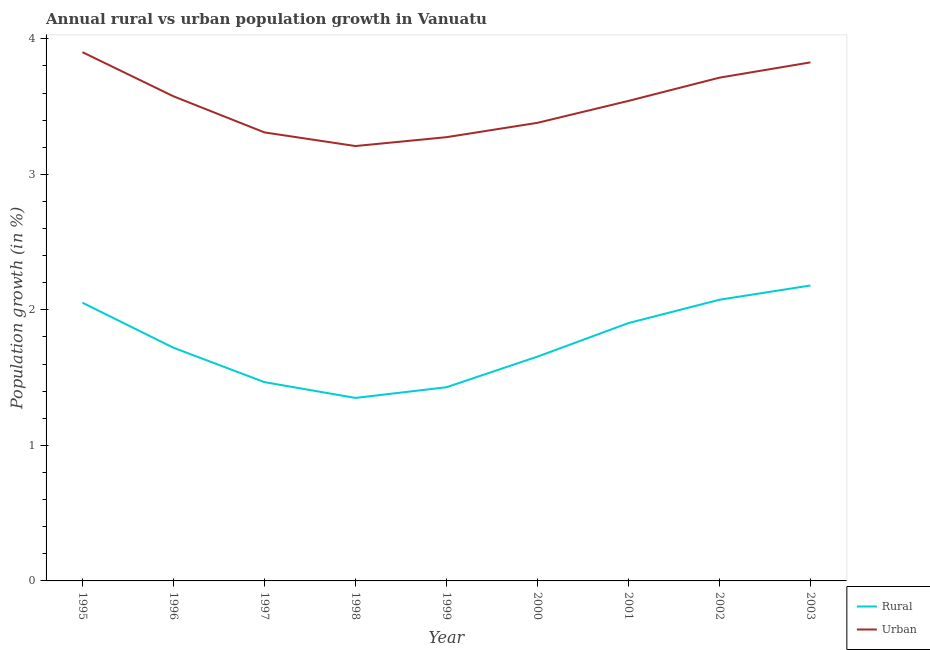How many different coloured lines are there?
Your answer should be very brief. 2. Is the number of lines equal to the number of legend labels?
Your response must be concise. Yes. What is the urban population growth in 1998?
Your answer should be very brief. 3.21. Across all years, what is the maximum rural population growth?
Provide a succinct answer. 2.18. Across all years, what is the minimum rural population growth?
Make the answer very short. 1.35. In which year was the rural population growth minimum?
Ensure brevity in your answer.  1998. What is the total urban population growth in the graph?
Make the answer very short. 31.73. What is the difference between the urban population growth in 1995 and that in 1996?
Make the answer very short. 0.33. What is the difference between the rural population growth in 1996 and the urban population growth in 1997?
Your response must be concise. -1.59. What is the average urban population growth per year?
Your answer should be very brief. 3.53. In the year 1995, what is the difference between the urban population growth and rural population growth?
Keep it short and to the point. 1.85. In how many years, is the rural population growth greater than 3.8 %?
Your answer should be very brief. 0. What is the ratio of the rural population growth in 1996 to that in 1997?
Your answer should be compact. 1.17. What is the difference between the highest and the second highest urban population growth?
Your answer should be very brief. 0.08. What is the difference between the highest and the lowest urban population growth?
Your answer should be compact. 0.69. Is the sum of the rural population growth in 1995 and 2003 greater than the maximum urban population growth across all years?
Give a very brief answer. Yes. Is the urban population growth strictly less than the rural population growth over the years?
Offer a terse response. No. How many years are there in the graph?
Keep it short and to the point. 9. What is the difference between two consecutive major ticks on the Y-axis?
Offer a terse response. 1. How many legend labels are there?
Make the answer very short. 2. What is the title of the graph?
Your answer should be compact. Annual rural vs urban population growth in Vanuatu. What is the label or title of the X-axis?
Your response must be concise. Year. What is the label or title of the Y-axis?
Ensure brevity in your answer.  Population growth (in %). What is the Population growth (in %) in Rural in 1995?
Provide a succinct answer. 2.05. What is the Population growth (in %) of Urban  in 1995?
Your response must be concise. 3.9. What is the Population growth (in %) in Rural in 1996?
Offer a very short reply. 1.72. What is the Population growth (in %) of Urban  in 1996?
Offer a very short reply. 3.58. What is the Population growth (in %) of Rural in 1997?
Offer a terse response. 1.47. What is the Population growth (in %) in Urban  in 1997?
Provide a short and direct response. 3.31. What is the Population growth (in %) in Rural in 1998?
Your answer should be very brief. 1.35. What is the Population growth (in %) in Urban  in 1998?
Offer a terse response. 3.21. What is the Population growth (in %) of Rural in 1999?
Provide a short and direct response. 1.43. What is the Population growth (in %) of Urban  in 1999?
Give a very brief answer. 3.27. What is the Population growth (in %) of Rural in 2000?
Your answer should be very brief. 1.65. What is the Population growth (in %) of Urban  in 2000?
Ensure brevity in your answer.  3.38. What is the Population growth (in %) of Rural in 2001?
Make the answer very short. 1.9. What is the Population growth (in %) in Urban  in 2001?
Your answer should be compact. 3.54. What is the Population growth (in %) in Rural in 2002?
Provide a succinct answer. 2.07. What is the Population growth (in %) in Urban  in 2002?
Your response must be concise. 3.71. What is the Population growth (in %) of Rural in 2003?
Provide a succinct answer. 2.18. What is the Population growth (in %) in Urban  in 2003?
Offer a terse response. 3.83. Across all years, what is the maximum Population growth (in %) of Rural?
Give a very brief answer. 2.18. Across all years, what is the maximum Population growth (in %) in Urban ?
Offer a very short reply. 3.9. Across all years, what is the minimum Population growth (in %) in Rural?
Give a very brief answer. 1.35. Across all years, what is the minimum Population growth (in %) in Urban ?
Ensure brevity in your answer.  3.21. What is the total Population growth (in %) of Rural in the graph?
Offer a very short reply. 15.83. What is the total Population growth (in %) of Urban  in the graph?
Ensure brevity in your answer.  31.73. What is the difference between the Population growth (in %) of Rural in 1995 and that in 1996?
Give a very brief answer. 0.33. What is the difference between the Population growth (in %) of Urban  in 1995 and that in 1996?
Your response must be concise. 0.33. What is the difference between the Population growth (in %) of Rural in 1995 and that in 1997?
Your answer should be very brief. 0.59. What is the difference between the Population growth (in %) of Urban  in 1995 and that in 1997?
Provide a succinct answer. 0.59. What is the difference between the Population growth (in %) of Rural in 1995 and that in 1998?
Provide a short and direct response. 0.7. What is the difference between the Population growth (in %) in Urban  in 1995 and that in 1998?
Your answer should be compact. 0.69. What is the difference between the Population growth (in %) of Rural in 1995 and that in 1999?
Ensure brevity in your answer.  0.62. What is the difference between the Population growth (in %) of Urban  in 1995 and that in 1999?
Provide a short and direct response. 0.63. What is the difference between the Population growth (in %) in Rural in 1995 and that in 2000?
Your answer should be very brief. 0.4. What is the difference between the Population growth (in %) in Urban  in 1995 and that in 2000?
Offer a terse response. 0.52. What is the difference between the Population growth (in %) in Rural in 1995 and that in 2001?
Ensure brevity in your answer.  0.15. What is the difference between the Population growth (in %) in Urban  in 1995 and that in 2001?
Give a very brief answer. 0.36. What is the difference between the Population growth (in %) in Rural in 1995 and that in 2002?
Your response must be concise. -0.02. What is the difference between the Population growth (in %) in Urban  in 1995 and that in 2002?
Make the answer very short. 0.19. What is the difference between the Population growth (in %) in Rural in 1995 and that in 2003?
Provide a short and direct response. -0.13. What is the difference between the Population growth (in %) of Urban  in 1995 and that in 2003?
Ensure brevity in your answer.  0.08. What is the difference between the Population growth (in %) in Rural in 1996 and that in 1997?
Your response must be concise. 0.25. What is the difference between the Population growth (in %) in Urban  in 1996 and that in 1997?
Offer a very short reply. 0.27. What is the difference between the Population growth (in %) of Rural in 1996 and that in 1998?
Your response must be concise. 0.37. What is the difference between the Population growth (in %) of Urban  in 1996 and that in 1998?
Offer a very short reply. 0.37. What is the difference between the Population growth (in %) in Rural in 1996 and that in 1999?
Give a very brief answer. 0.29. What is the difference between the Population growth (in %) in Urban  in 1996 and that in 1999?
Offer a terse response. 0.3. What is the difference between the Population growth (in %) of Rural in 1996 and that in 2000?
Make the answer very short. 0.07. What is the difference between the Population growth (in %) of Urban  in 1996 and that in 2000?
Your answer should be compact. 0.2. What is the difference between the Population growth (in %) of Rural in 1996 and that in 2001?
Offer a very short reply. -0.18. What is the difference between the Population growth (in %) in Urban  in 1996 and that in 2001?
Provide a short and direct response. 0.03. What is the difference between the Population growth (in %) in Rural in 1996 and that in 2002?
Provide a succinct answer. -0.35. What is the difference between the Population growth (in %) in Urban  in 1996 and that in 2002?
Provide a succinct answer. -0.14. What is the difference between the Population growth (in %) of Rural in 1996 and that in 2003?
Ensure brevity in your answer.  -0.46. What is the difference between the Population growth (in %) of Urban  in 1996 and that in 2003?
Offer a terse response. -0.25. What is the difference between the Population growth (in %) of Rural in 1997 and that in 1998?
Keep it short and to the point. 0.12. What is the difference between the Population growth (in %) in Urban  in 1997 and that in 1998?
Ensure brevity in your answer.  0.1. What is the difference between the Population growth (in %) of Rural in 1997 and that in 1999?
Your answer should be very brief. 0.04. What is the difference between the Population growth (in %) in Urban  in 1997 and that in 1999?
Provide a short and direct response. 0.04. What is the difference between the Population growth (in %) in Rural in 1997 and that in 2000?
Ensure brevity in your answer.  -0.19. What is the difference between the Population growth (in %) of Urban  in 1997 and that in 2000?
Provide a short and direct response. -0.07. What is the difference between the Population growth (in %) in Rural in 1997 and that in 2001?
Keep it short and to the point. -0.44. What is the difference between the Population growth (in %) in Urban  in 1997 and that in 2001?
Keep it short and to the point. -0.23. What is the difference between the Population growth (in %) in Rural in 1997 and that in 2002?
Your answer should be very brief. -0.61. What is the difference between the Population growth (in %) in Urban  in 1997 and that in 2002?
Your answer should be compact. -0.4. What is the difference between the Population growth (in %) of Rural in 1997 and that in 2003?
Your answer should be very brief. -0.71. What is the difference between the Population growth (in %) of Urban  in 1997 and that in 2003?
Provide a short and direct response. -0.52. What is the difference between the Population growth (in %) of Rural in 1998 and that in 1999?
Give a very brief answer. -0.08. What is the difference between the Population growth (in %) of Urban  in 1998 and that in 1999?
Your response must be concise. -0.07. What is the difference between the Population growth (in %) in Rural in 1998 and that in 2000?
Give a very brief answer. -0.3. What is the difference between the Population growth (in %) in Urban  in 1998 and that in 2000?
Make the answer very short. -0.17. What is the difference between the Population growth (in %) in Rural in 1998 and that in 2001?
Provide a short and direct response. -0.55. What is the difference between the Population growth (in %) in Urban  in 1998 and that in 2001?
Provide a succinct answer. -0.33. What is the difference between the Population growth (in %) in Rural in 1998 and that in 2002?
Make the answer very short. -0.72. What is the difference between the Population growth (in %) in Urban  in 1998 and that in 2002?
Provide a short and direct response. -0.5. What is the difference between the Population growth (in %) of Rural in 1998 and that in 2003?
Your answer should be very brief. -0.83. What is the difference between the Population growth (in %) in Urban  in 1998 and that in 2003?
Provide a short and direct response. -0.62. What is the difference between the Population growth (in %) of Rural in 1999 and that in 2000?
Your answer should be very brief. -0.23. What is the difference between the Population growth (in %) of Urban  in 1999 and that in 2000?
Offer a very short reply. -0.11. What is the difference between the Population growth (in %) in Rural in 1999 and that in 2001?
Give a very brief answer. -0.47. What is the difference between the Population growth (in %) in Urban  in 1999 and that in 2001?
Provide a succinct answer. -0.27. What is the difference between the Population growth (in %) in Rural in 1999 and that in 2002?
Your answer should be very brief. -0.65. What is the difference between the Population growth (in %) of Urban  in 1999 and that in 2002?
Your answer should be very brief. -0.44. What is the difference between the Population growth (in %) of Rural in 1999 and that in 2003?
Provide a short and direct response. -0.75. What is the difference between the Population growth (in %) of Urban  in 1999 and that in 2003?
Your response must be concise. -0.55. What is the difference between the Population growth (in %) of Rural in 2000 and that in 2001?
Your answer should be very brief. -0.25. What is the difference between the Population growth (in %) in Urban  in 2000 and that in 2001?
Offer a terse response. -0.16. What is the difference between the Population growth (in %) in Rural in 2000 and that in 2002?
Make the answer very short. -0.42. What is the difference between the Population growth (in %) in Urban  in 2000 and that in 2002?
Give a very brief answer. -0.33. What is the difference between the Population growth (in %) in Rural in 2000 and that in 2003?
Provide a succinct answer. -0.53. What is the difference between the Population growth (in %) of Urban  in 2000 and that in 2003?
Ensure brevity in your answer.  -0.45. What is the difference between the Population growth (in %) in Rural in 2001 and that in 2002?
Provide a short and direct response. -0.17. What is the difference between the Population growth (in %) in Urban  in 2001 and that in 2002?
Your answer should be very brief. -0.17. What is the difference between the Population growth (in %) in Rural in 2001 and that in 2003?
Your answer should be compact. -0.28. What is the difference between the Population growth (in %) of Urban  in 2001 and that in 2003?
Provide a succinct answer. -0.28. What is the difference between the Population growth (in %) of Rural in 2002 and that in 2003?
Provide a succinct answer. -0.11. What is the difference between the Population growth (in %) of Urban  in 2002 and that in 2003?
Ensure brevity in your answer.  -0.11. What is the difference between the Population growth (in %) of Rural in 1995 and the Population growth (in %) of Urban  in 1996?
Keep it short and to the point. -1.52. What is the difference between the Population growth (in %) in Rural in 1995 and the Population growth (in %) in Urban  in 1997?
Your answer should be compact. -1.26. What is the difference between the Population growth (in %) of Rural in 1995 and the Population growth (in %) of Urban  in 1998?
Provide a succinct answer. -1.16. What is the difference between the Population growth (in %) of Rural in 1995 and the Population growth (in %) of Urban  in 1999?
Give a very brief answer. -1.22. What is the difference between the Population growth (in %) in Rural in 1995 and the Population growth (in %) in Urban  in 2000?
Give a very brief answer. -1.33. What is the difference between the Population growth (in %) of Rural in 1995 and the Population growth (in %) of Urban  in 2001?
Keep it short and to the point. -1.49. What is the difference between the Population growth (in %) in Rural in 1995 and the Population growth (in %) in Urban  in 2002?
Offer a very short reply. -1.66. What is the difference between the Population growth (in %) in Rural in 1995 and the Population growth (in %) in Urban  in 2003?
Your response must be concise. -1.77. What is the difference between the Population growth (in %) of Rural in 1996 and the Population growth (in %) of Urban  in 1997?
Give a very brief answer. -1.59. What is the difference between the Population growth (in %) of Rural in 1996 and the Population growth (in %) of Urban  in 1998?
Your response must be concise. -1.49. What is the difference between the Population growth (in %) in Rural in 1996 and the Population growth (in %) in Urban  in 1999?
Provide a succinct answer. -1.55. What is the difference between the Population growth (in %) in Rural in 1996 and the Population growth (in %) in Urban  in 2000?
Ensure brevity in your answer.  -1.66. What is the difference between the Population growth (in %) in Rural in 1996 and the Population growth (in %) in Urban  in 2001?
Ensure brevity in your answer.  -1.82. What is the difference between the Population growth (in %) in Rural in 1996 and the Population growth (in %) in Urban  in 2002?
Give a very brief answer. -1.99. What is the difference between the Population growth (in %) of Rural in 1996 and the Population growth (in %) of Urban  in 2003?
Your answer should be compact. -2.11. What is the difference between the Population growth (in %) of Rural in 1997 and the Population growth (in %) of Urban  in 1998?
Ensure brevity in your answer.  -1.74. What is the difference between the Population growth (in %) of Rural in 1997 and the Population growth (in %) of Urban  in 1999?
Offer a terse response. -1.81. What is the difference between the Population growth (in %) in Rural in 1997 and the Population growth (in %) in Urban  in 2000?
Make the answer very short. -1.91. What is the difference between the Population growth (in %) of Rural in 1997 and the Population growth (in %) of Urban  in 2001?
Your answer should be compact. -2.08. What is the difference between the Population growth (in %) of Rural in 1997 and the Population growth (in %) of Urban  in 2002?
Give a very brief answer. -2.25. What is the difference between the Population growth (in %) of Rural in 1997 and the Population growth (in %) of Urban  in 2003?
Offer a terse response. -2.36. What is the difference between the Population growth (in %) of Rural in 1998 and the Population growth (in %) of Urban  in 1999?
Provide a succinct answer. -1.92. What is the difference between the Population growth (in %) in Rural in 1998 and the Population growth (in %) in Urban  in 2000?
Keep it short and to the point. -2.03. What is the difference between the Population growth (in %) of Rural in 1998 and the Population growth (in %) of Urban  in 2001?
Your response must be concise. -2.19. What is the difference between the Population growth (in %) of Rural in 1998 and the Population growth (in %) of Urban  in 2002?
Your answer should be compact. -2.36. What is the difference between the Population growth (in %) in Rural in 1998 and the Population growth (in %) in Urban  in 2003?
Provide a short and direct response. -2.48. What is the difference between the Population growth (in %) of Rural in 1999 and the Population growth (in %) of Urban  in 2000?
Offer a terse response. -1.95. What is the difference between the Population growth (in %) in Rural in 1999 and the Population growth (in %) in Urban  in 2001?
Provide a succinct answer. -2.11. What is the difference between the Population growth (in %) in Rural in 1999 and the Population growth (in %) in Urban  in 2002?
Give a very brief answer. -2.28. What is the difference between the Population growth (in %) in Rural in 1999 and the Population growth (in %) in Urban  in 2003?
Ensure brevity in your answer.  -2.4. What is the difference between the Population growth (in %) in Rural in 2000 and the Population growth (in %) in Urban  in 2001?
Your answer should be very brief. -1.89. What is the difference between the Population growth (in %) in Rural in 2000 and the Population growth (in %) in Urban  in 2002?
Make the answer very short. -2.06. What is the difference between the Population growth (in %) of Rural in 2000 and the Population growth (in %) of Urban  in 2003?
Provide a succinct answer. -2.17. What is the difference between the Population growth (in %) in Rural in 2001 and the Population growth (in %) in Urban  in 2002?
Your response must be concise. -1.81. What is the difference between the Population growth (in %) in Rural in 2001 and the Population growth (in %) in Urban  in 2003?
Provide a short and direct response. -1.92. What is the difference between the Population growth (in %) in Rural in 2002 and the Population growth (in %) in Urban  in 2003?
Offer a very short reply. -1.75. What is the average Population growth (in %) of Rural per year?
Ensure brevity in your answer.  1.76. What is the average Population growth (in %) in Urban  per year?
Ensure brevity in your answer.  3.53. In the year 1995, what is the difference between the Population growth (in %) of Rural and Population growth (in %) of Urban ?
Make the answer very short. -1.85. In the year 1996, what is the difference between the Population growth (in %) of Rural and Population growth (in %) of Urban ?
Offer a terse response. -1.86. In the year 1997, what is the difference between the Population growth (in %) in Rural and Population growth (in %) in Urban ?
Make the answer very short. -1.84. In the year 1998, what is the difference between the Population growth (in %) of Rural and Population growth (in %) of Urban ?
Offer a very short reply. -1.86. In the year 1999, what is the difference between the Population growth (in %) in Rural and Population growth (in %) in Urban ?
Offer a very short reply. -1.85. In the year 2000, what is the difference between the Population growth (in %) of Rural and Population growth (in %) of Urban ?
Your answer should be very brief. -1.73. In the year 2001, what is the difference between the Population growth (in %) in Rural and Population growth (in %) in Urban ?
Keep it short and to the point. -1.64. In the year 2002, what is the difference between the Population growth (in %) of Rural and Population growth (in %) of Urban ?
Provide a succinct answer. -1.64. In the year 2003, what is the difference between the Population growth (in %) of Rural and Population growth (in %) of Urban ?
Provide a short and direct response. -1.65. What is the ratio of the Population growth (in %) in Rural in 1995 to that in 1996?
Make the answer very short. 1.19. What is the ratio of the Population growth (in %) in Urban  in 1995 to that in 1996?
Offer a terse response. 1.09. What is the ratio of the Population growth (in %) in Rural in 1995 to that in 1997?
Make the answer very short. 1.4. What is the ratio of the Population growth (in %) in Urban  in 1995 to that in 1997?
Ensure brevity in your answer.  1.18. What is the ratio of the Population growth (in %) in Rural in 1995 to that in 1998?
Your answer should be compact. 1.52. What is the ratio of the Population growth (in %) in Urban  in 1995 to that in 1998?
Your answer should be very brief. 1.22. What is the ratio of the Population growth (in %) of Rural in 1995 to that in 1999?
Your answer should be compact. 1.44. What is the ratio of the Population growth (in %) of Urban  in 1995 to that in 1999?
Your answer should be very brief. 1.19. What is the ratio of the Population growth (in %) of Rural in 1995 to that in 2000?
Your answer should be compact. 1.24. What is the ratio of the Population growth (in %) of Urban  in 1995 to that in 2000?
Provide a short and direct response. 1.15. What is the ratio of the Population growth (in %) of Rural in 1995 to that in 2001?
Give a very brief answer. 1.08. What is the ratio of the Population growth (in %) in Urban  in 1995 to that in 2001?
Offer a terse response. 1.1. What is the ratio of the Population growth (in %) of Rural in 1995 to that in 2002?
Give a very brief answer. 0.99. What is the ratio of the Population growth (in %) in Urban  in 1995 to that in 2002?
Your answer should be very brief. 1.05. What is the ratio of the Population growth (in %) of Rural in 1995 to that in 2003?
Ensure brevity in your answer.  0.94. What is the ratio of the Population growth (in %) in Urban  in 1995 to that in 2003?
Your response must be concise. 1.02. What is the ratio of the Population growth (in %) of Rural in 1996 to that in 1997?
Keep it short and to the point. 1.17. What is the ratio of the Population growth (in %) in Urban  in 1996 to that in 1997?
Give a very brief answer. 1.08. What is the ratio of the Population growth (in %) of Rural in 1996 to that in 1998?
Provide a succinct answer. 1.27. What is the ratio of the Population growth (in %) in Urban  in 1996 to that in 1998?
Ensure brevity in your answer.  1.11. What is the ratio of the Population growth (in %) in Rural in 1996 to that in 1999?
Provide a succinct answer. 1.2. What is the ratio of the Population growth (in %) in Urban  in 1996 to that in 1999?
Ensure brevity in your answer.  1.09. What is the ratio of the Population growth (in %) in Rural in 1996 to that in 2000?
Offer a terse response. 1.04. What is the ratio of the Population growth (in %) of Urban  in 1996 to that in 2000?
Offer a terse response. 1.06. What is the ratio of the Population growth (in %) in Rural in 1996 to that in 2001?
Offer a terse response. 0.9. What is the ratio of the Population growth (in %) in Urban  in 1996 to that in 2001?
Your answer should be very brief. 1.01. What is the ratio of the Population growth (in %) of Rural in 1996 to that in 2002?
Make the answer very short. 0.83. What is the ratio of the Population growth (in %) in Rural in 1996 to that in 2003?
Offer a terse response. 0.79. What is the ratio of the Population growth (in %) of Urban  in 1996 to that in 2003?
Provide a short and direct response. 0.93. What is the ratio of the Population growth (in %) in Rural in 1997 to that in 1998?
Ensure brevity in your answer.  1.09. What is the ratio of the Population growth (in %) of Urban  in 1997 to that in 1998?
Offer a very short reply. 1.03. What is the ratio of the Population growth (in %) in Rural in 1997 to that in 1999?
Provide a succinct answer. 1.03. What is the ratio of the Population growth (in %) in Urban  in 1997 to that in 1999?
Provide a succinct answer. 1.01. What is the ratio of the Population growth (in %) of Rural in 1997 to that in 2000?
Keep it short and to the point. 0.89. What is the ratio of the Population growth (in %) of Urban  in 1997 to that in 2000?
Offer a terse response. 0.98. What is the ratio of the Population growth (in %) of Rural in 1997 to that in 2001?
Offer a terse response. 0.77. What is the ratio of the Population growth (in %) in Urban  in 1997 to that in 2001?
Offer a terse response. 0.93. What is the ratio of the Population growth (in %) of Rural in 1997 to that in 2002?
Your answer should be very brief. 0.71. What is the ratio of the Population growth (in %) in Urban  in 1997 to that in 2002?
Offer a very short reply. 0.89. What is the ratio of the Population growth (in %) in Rural in 1997 to that in 2003?
Make the answer very short. 0.67. What is the ratio of the Population growth (in %) in Urban  in 1997 to that in 2003?
Keep it short and to the point. 0.86. What is the ratio of the Population growth (in %) of Rural in 1998 to that in 1999?
Provide a short and direct response. 0.94. What is the ratio of the Population growth (in %) of Rural in 1998 to that in 2000?
Provide a succinct answer. 0.82. What is the ratio of the Population growth (in %) of Urban  in 1998 to that in 2000?
Offer a terse response. 0.95. What is the ratio of the Population growth (in %) of Rural in 1998 to that in 2001?
Provide a succinct answer. 0.71. What is the ratio of the Population growth (in %) in Urban  in 1998 to that in 2001?
Keep it short and to the point. 0.91. What is the ratio of the Population growth (in %) of Rural in 1998 to that in 2002?
Keep it short and to the point. 0.65. What is the ratio of the Population growth (in %) of Urban  in 1998 to that in 2002?
Offer a very short reply. 0.86. What is the ratio of the Population growth (in %) of Rural in 1998 to that in 2003?
Your response must be concise. 0.62. What is the ratio of the Population growth (in %) of Urban  in 1998 to that in 2003?
Your response must be concise. 0.84. What is the ratio of the Population growth (in %) in Rural in 1999 to that in 2000?
Give a very brief answer. 0.86. What is the ratio of the Population growth (in %) in Urban  in 1999 to that in 2000?
Make the answer very short. 0.97. What is the ratio of the Population growth (in %) of Rural in 1999 to that in 2001?
Provide a short and direct response. 0.75. What is the ratio of the Population growth (in %) in Urban  in 1999 to that in 2001?
Your answer should be very brief. 0.92. What is the ratio of the Population growth (in %) in Rural in 1999 to that in 2002?
Ensure brevity in your answer.  0.69. What is the ratio of the Population growth (in %) in Urban  in 1999 to that in 2002?
Keep it short and to the point. 0.88. What is the ratio of the Population growth (in %) in Rural in 1999 to that in 2003?
Provide a succinct answer. 0.66. What is the ratio of the Population growth (in %) of Urban  in 1999 to that in 2003?
Offer a very short reply. 0.86. What is the ratio of the Population growth (in %) in Rural in 2000 to that in 2001?
Your response must be concise. 0.87. What is the ratio of the Population growth (in %) of Urban  in 2000 to that in 2001?
Ensure brevity in your answer.  0.95. What is the ratio of the Population growth (in %) in Rural in 2000 to that in 2002?
Provide a succinct answer. 0.8. What is the ratio of the Population growth (in %) of Urban  in 2000 to that in 2002?
Keep it short and to the point. 0.91. What is the ratio of the Population growth (in %) of Rural in 2000 to that in 2003?
Your response must be concise. 0.76. What is the ratio of the Population growth (in %) of Urban  in 2000 to that in 2003?
Provide a short and direct response. 0.88. What is the ratio of the Population growth (in %) of Rural in 2001 to that in 2002?
Provide a short and direct response. 0.92. What is the ratio of the Population growth (in %) of Urban  in 2001 to that in 2002?
Ensure brevity in your answer.  0.95. What is the ratio of the Population growth (in %) of Rural in 2001 to that in 2003?
Provide a succinct answer. 0.87. What is the ratio of the Population growth (in %) of Urban  in 2001 to that in 2003?
Provide a succinct answer. 0.93. What is the ratio of the Population growth (in %) in Rural in 2002 to that in 2003?
Make the answer very short. 0.95. What is the ratio of the Population growth (in %) in Urban  in 2002 to that in 2003?
Make the answer very short. 0.97. What is the difference between the highest and the second highest Population growth (in %) of Rural?
Ensure brevity in your answer.  0.11. What is the difference between the highest and the second highest Population growth (in %) in Urban ?
Provide a short and direct response. 0.08. What is the difference between the highest and the lowest Population growth (in %) in Rural?
Make the answer very short. 0.83. What is the difference between the highest and the lowest Population growth (in %) of Urban ?
Your answer should be very brief. 0.69. 